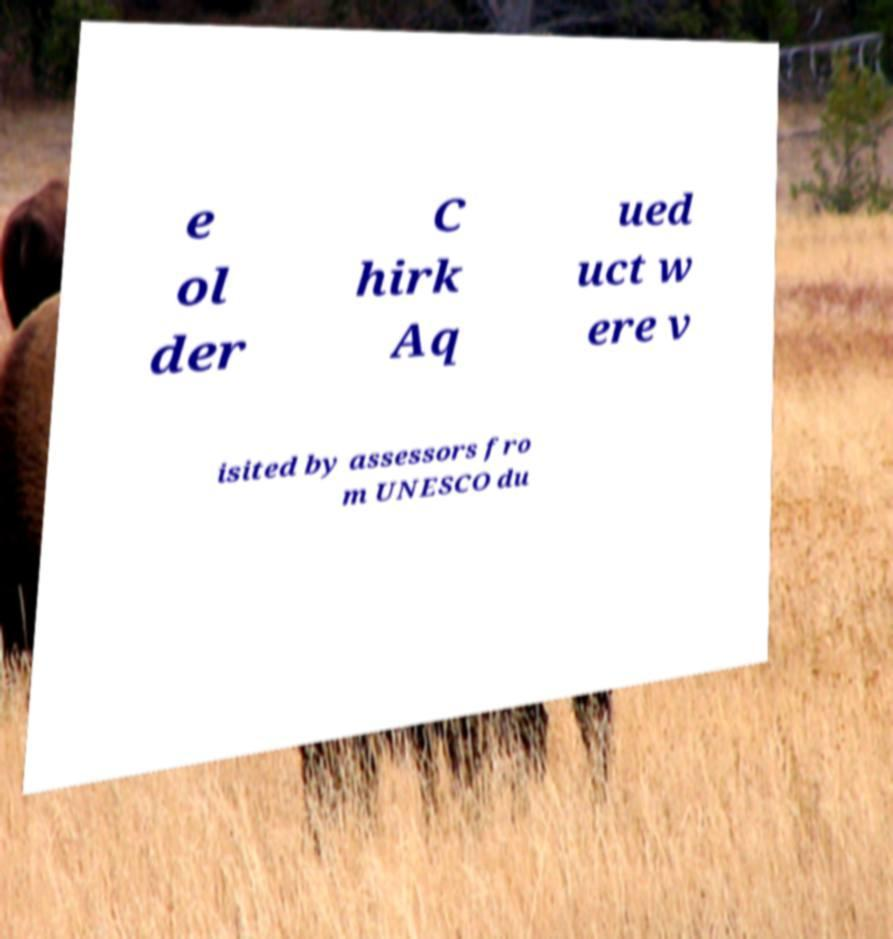Could you extract and type out the text from this image? e ol der C hirk Aq ued uct w ere v isited by assessors fro m UNESCO du 